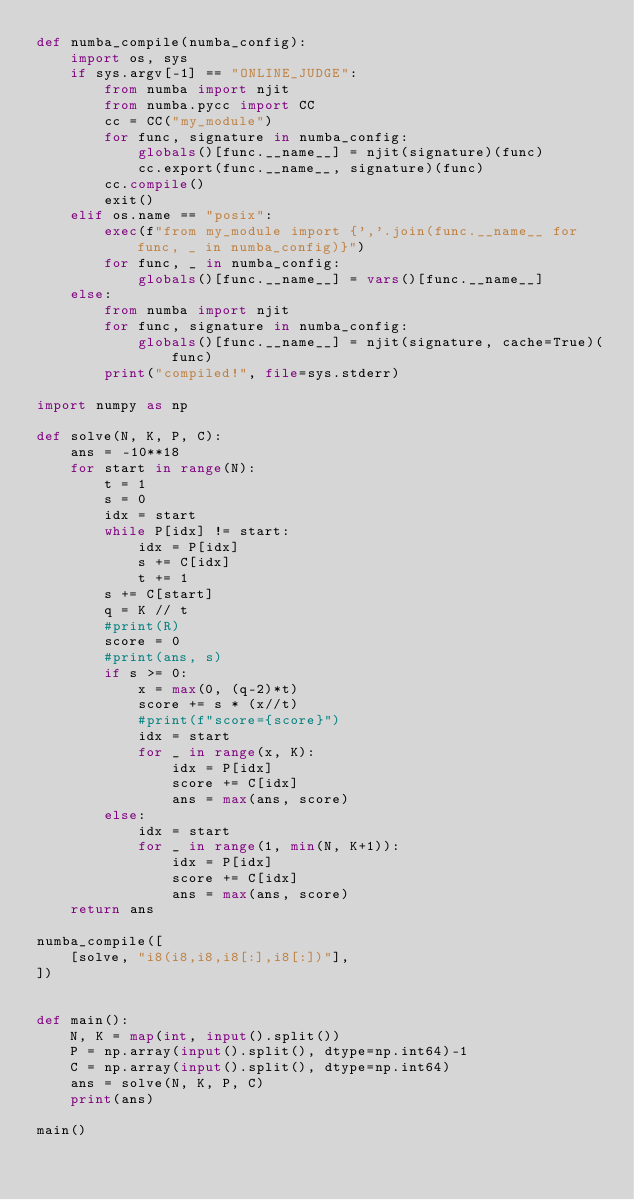<code> <loc_0><loc_0><loc_500><loc_500><_Python_>def numba_compile(numba_config):
    import os, sys
    if sys.argv[-1] == "ONLINE_JUDGE":
        from numba import njit
        from numba.pycc import CC
        cc = CC("my_module")
        for func, signature in numba_config:
            globals()[func.__name__] = njit(signature)(func)
            cc.export(func.__name__, signature)(func)
        cc.compile()
        exit()
    elif os.name == "posix":
        exec(f"from my_module import {','.join(func.__name__ for func, _ in numba_config)}")
        for func, _ in numba_config:
            globals()[func.__name__] = vars()[func.__name__]
    else:
        from numba import njit
        for func, signature in numba_config:
            globals()[func.__name__] = njit(signature, cache=True)(func)
        print("compiled!", file=sys.stderr)

import numpy as np

def solve(N, K, P, C):
    ans = -10**18
    for start in range(N):
        t = 1
        s = 0
        idx = start
        while P[idx] != start:
            idx = P[idx]
            s += C[idx]
            t += 1
        s += C[start]
        q = K // t
        #print(R)
        score = 0
        #print(ans, s)
        if s >= 0:
            x = max(0, (q-2)*t)
            score += s * (x//t)
            #print(f"score={score}")
            idx = start
            for _ in range(x, K):
                idx = P[idx]
                score += C[idx]
                ans = max(ans, score)
        else:
            idx = start
            for _ in range(1, min(N, K+1)):
                idx = P[idx]
                score += C[idx]
                ans = max(ans, score)
    return ans

numba_compile([
    [solve, "i8(i8,i8,i8[:],i8[:])"],
])


def main():
    N, K = map(int, input().split())
    P = np.array(input().split(), dtype=np.int64)-1
    C = np.array(input().split(), dtype=np.int64)
    ans = solve(N, K, P, C)
    print(ans)

main()
</code> 